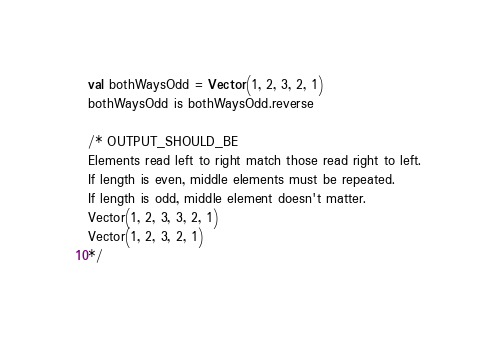Convert code to text. <code><loc_0><loc_0><loc_500><loc_500><_Scala_>val bothWaysOdd = Vector(1, 2, 3, 2, 1)
bothWaysOdd is bothWaysOdd.reverse

/* OUTPUT_SHOULD_BE
Elements read left to right match those read right to left.
If length is even, middle elements must be repeated.
If length is odd, middle element doesn't matter.
Vector(1, 2, 3, 3, 2, 1)
Vector(1, 2, 3, 2, 1)
*/
</code> 